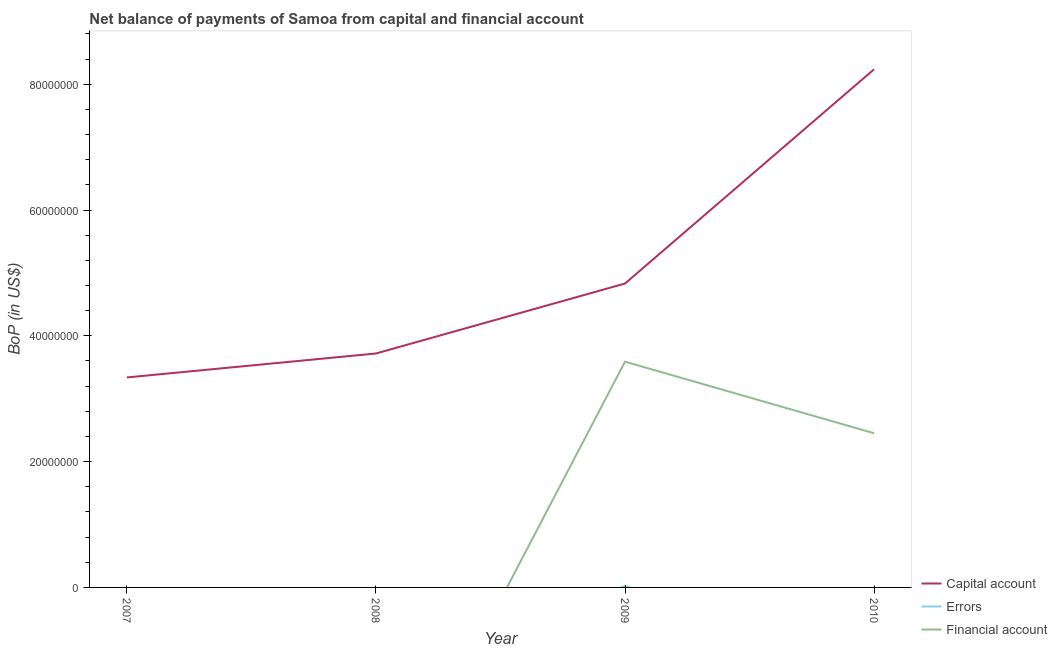Does the line corresponding to amount of net capital account intersect with the line corresponding to amount of financial account?
Keep it short and to the point. No. Is the number of lines equal to the number of legend labels?
Make the answer very short. No. What is the amount of net capital account in 2008?
Your response must be concise. 3.72e+07. Across all years, what is the maximum amount of financial account?
Your answer should be compact. 3.59e+07. Across all years, what is the minimum amount of net capital account?
Provide a short and direct response. 3.34e+07. What is the total amount of errors in the graph?
Give a very brief answer. 2.61e+05. What is the difference between the amount of net capital account in 2009 and that in 2010?
Make the answer very short. -3.41e+07. What is the difference between the amount of net capital account in 2010 and the amount of financial account in 2007?
Make the answer very short. 8.24e+07. What is the average amount of financial account per year?
Your answer should be compact. 1.51e+07. In the year 2009, what is the difference between the amount of errors and amount of net capital account?
Your answer should be compact. -4.81e+07. What is the ratio of the amount of net capital account in 2007 to that in 2010?
Provide a short and direct response. 0.41. What is the difference between the highest and the second highest amount of net capital account?
Your answer should be very brief. 3.41e+07. What is the difference between the highest and the lowest amount of net capital account?
Provide a succinct answer. 4.90e+07. Is it the case that in every year, the sum of the amount of net capital account and amount of errors is greater than the amount of financial account?
Offer a terse response. Yes. Is the amount of net capital account strictly greater than the amount of errors over the years?
Make the answer very short. Yes. Is the amount of financial account strictly less than the amount of net capital account over the years?
Offer a terse response. Yes. Are the values on the major ticks of Y-axis written in scientific E-notation?
Provide a succinct answer. No. Does the graph contain any zero values?
Your response must be concise. Yes. Where does the legend appear in the graph?
Your answer should be very brief. Bottom right. What is the title of the graph?
Your answer should be very brief. Net balance of payments of Samoa from capital and financial account. Does "Self-employed" appear as one of the legend labels in the graph?
Offer a terse response. No. What is the label or title of the Y-axis?
Your answer should be compact. BoP (in US$). What is the BoP (in US$) in Capital account in 2007?
Ensure brevity in your answer.  3.34e+07. What is the BoP (in US$) in Capital account in 2008?
Your answer should be very brief. 3.72e+07. What is the BoP (in US$) in Errors in 2008?
Offer a terse response. 0. What is the BoP (in US$) of Capital account in 2009?
Offer a very short reply. 4.83e+07. What is the BoP (in US$) of Errors in 2009?
Your answer should be very brief. 2.61e+05. What is the BoP (in US$) in Financial account in 2009?
Ensure brevity in your answer.  3.59e+07. What is the BoP (in US$) in Capital account in 2010?
Give a very brief answer. 8.24e+07. What is the BoP (in US$) in Financial account in 2010?
Give a very brief answer. 2.45e+07. Across all years, what is the maximum BoP (in US$) in Capital account?
Your response must be concise. 8.24e+07. Across all years, what is the maximum BoP (in US$) of Errors?
Your answer should be very brief. 2.61e+05. Across all years, what is the maximum BoP (in US$) in Financial account?
Provide a short and direct response. 3.59e+07. Across all years, what is the minimum BoP (in US$) of Capital account?
Your answer should be very brief. 3.34e+07. Across all years, what is the minimum BoP (in US$) of Errors?
Your response must be concise. 0. What is the total BoP (in US$) in Capital account in the graph?
Ensure brevity in your answer.  2.01e+08. What is the total BoP (in US$) of Errors in the graph?
Keep it short and to the point. 2.61e+05. What is the total BoP (in US$) in Financial account in the graph?
Offer a terse response. 6.04e+07. What is the difference between the BoP (in US$) of Capital account in 2007 and that in 2008?
Keep it short and to the point. -3.81e+06. What is the difference between the BoP (in US$) in Capital account in 2007 and that in 2009?
Offer a terse response. -1.49e+07. What is the difference between the BoP (in US$) in Capital account in 2007 and that in 2010?
Offer a very short reply. -4.90e+07. What is the difference between the BoP (in US$) in Capital account in 2008 and that in 2009?
Give a very brief answer. -1.11e+07. What is the difference between the BoP (in US$) in Capital account in 2008 and that in 2010?
Your response must be concise. -4.52e+07. What is the difference between the BoP (in US$) in Capital account in 2009 and that in 2010?
Your response must be concise. -3.41e+07. What is the difference between the BoP (in US$) in Financial account in 2009 and that in 2010?
Provide a succinct answer. 1.14e+07. What is the difference between the BoP (in US$) in Capital account in 2007 and the BoP (in US$) in Errors in 2009?
Your answer should be compact. 3.31e+07. What is the difference between the BoP (in US$) of Capital account in 2007 and the BoP (in US$) of Financial account in 2009?
Ensure brevity in your answer.  -2.51e+06. What is the difference between the BoP (in US$) of Capital account in 2007 and the BoP (in US$) of Financial account in 2010?
Your answer should be very brief. 8.87e+06. What is the difference between the BoP (in US$) of Capital account in 2008 and the BoP (in US$) of Errors in 2009?
Your response must be concise. 3.69e+07. What is the difference between the BoP (in US$) in Capital account in 2008 and the BoP (in US$) in Financial account in 2009?
Give a very brief answer. 1.30e+06. What is the difference between the BoP (in US$) in Capital account in 2008 and the BoP (in US$) in Financial account in 2010?
Provide a short and direct response. 1.27e+07. What is the difference between the BoP (in US$) in Capital account in 2009 and the BoP (in US$) in Financial account in 2010?
Provide a succinct answer. 2.38e+07. What is the difference between the BoP (in US$) of Errors in 2009 and the BoP (in US$) of Financial account in 2010?
Keep it short and to the point. -2.42e+07. What is the average BoP (in US$) in Capital account per year?
Make the answer very short. 5.03e+07. What is the average BoP (in US$) in Errors per year?
Provide a short and direct response. 6.53e+04. What is the average BoP (in US$) of Financial account per year?
Your answer should be compact. 1.51e+07. In the year 2009, what is the difference between the BoP (in US$) of Capital account and BoP (in US$) of Errors?
Offer a terse response. 4.81e+07. In the year 2009, what is the difference between the BoP (in US$) of Capital account and BoP (in US$) of Financial account?
Your response must be concise. 1.24e+07. In the year 2009, what is the difference between the BoP (in US$) in Errors and BoP (in US$) in Financial account?
Offer a very short reply. -3.56e+07. In the year 2010, what is the difference between the BoP (in US$) in Capital account and BoP (in US$) in Financial account?
Your response must be concise. 5.79e+07. What is the ratio of the BoP (in US$) of Capital account in 2007 to that in 2008?
Give a very brief answer. 0.9. What is the ratio of the BoP (in US$) of Capital account in 2007 to that in 2009?
Your answer should be very brief. 0.69. What is the ratio of the BoP (in US$) of Capital account in 2007 to that in 2010?
Your answer should be very brief. 0.41. What is the ratio of the BoP (in US$) in Capital account in 2008 to that in 2009?
Your answer should be compact. 0.77. What is the ratio of the BoP (in US$) in Capital account in 2008 to that in 2010?
Your response must be concise. 0.45. What is the ratio of the BoP (in US$) in Capital account in 2009 to that in 2010?
Provide a succinct answer. 0.59. What is the ratio of the BoP (in US$) in Financial account in 2009 to that in 2010?
Your response must be concise. 1.46. What is the difference between the highest and the second highest BoP (in US$) in Capital account?
Give a very brief answer. 3.41e+07. What is the difference between the highest and the lowest BoP (in US$) of Capital account?
Offer a terse response. 4.90e+07. What is the difference between the highest and the lowest BoP (in US$) of Errors?
Ensure brevity in your answer.  2.61e+05. What is the difference between the highest and the lowest BoP (in US$) of Financial account?
Ensure brevity in your answer.  3.59e+07. 